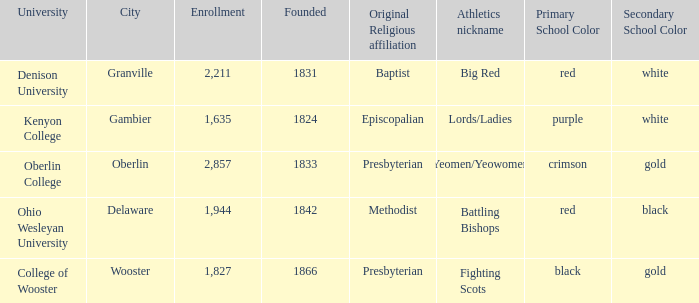What was the religious affiliation for the athletics nicknamed lords/ladies? (Originally Episcopalian). 